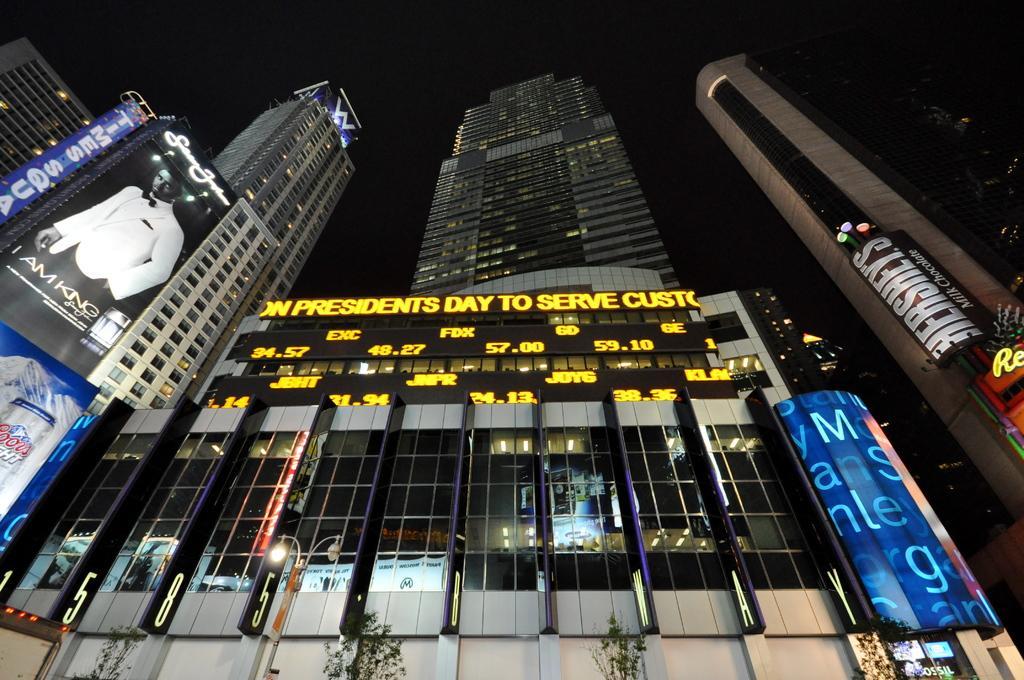How would you summarize this image in a sentence or two? In this image we can see skyscrapers, advertisements and sky in the background. At the bottom of the image there are trees, street poles and street lights. 